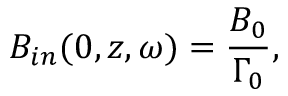Convert formula to latex. <formula><loc_0><loc_0><loc_500><loc_500>B _ { i n } ( 0 , z , \omega ) = \frac { B _ { 0 } } { \Gamma _ { 0 } } ,</formula> 